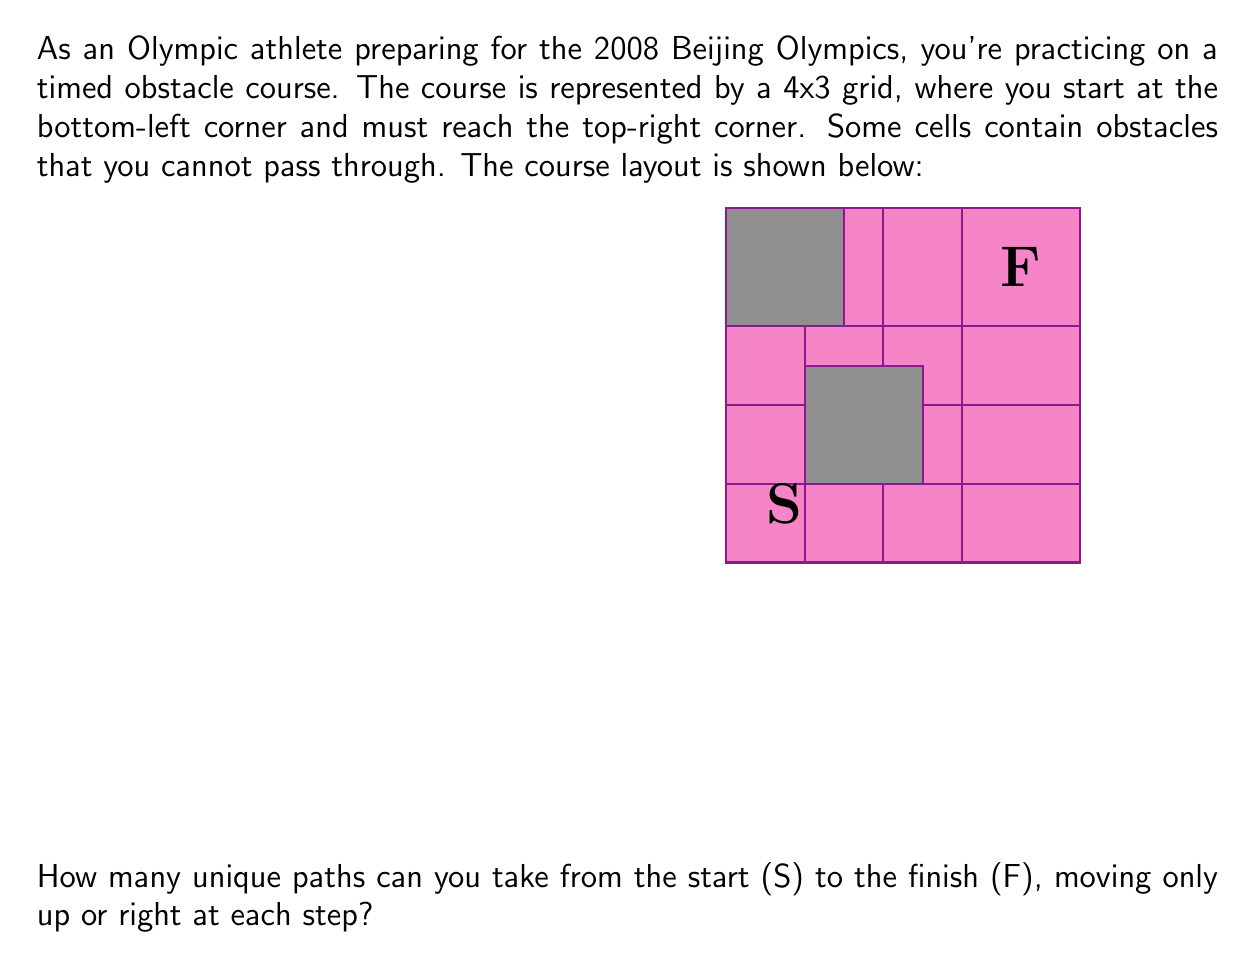Give your solution to this math problem. Let's approach this step-by-step:

1) First, we need to understand that this is a combinatorics problem where we're counting paths on a grid with obstacles.

2) We can solve this using dynamic programming. Let's create a 4x3 matrix where each cell represents the number of ways to reach that cell from the start.

3) Initialize the matrix:
   - Set the start position (0,0) to 1
   - Set obstacle positions to 0
   - Set all other positions to 0 initially

4) Fill the matrix:
   - For each cell (i,j), the number of ways to reach it is the sum of ways to reach the cell to its left (i,j-1) and the cell below it (i-1,j)
   - Skip obstacle cells

5) Let's fill the matrix step by step:

   $$\begin{bmatrix}
   0 & 0 & 1 \\
   0 & 0 & 1 \\
   1 & 1 & 2 \\
   1 & 1 & 3
   \end{bmatrix}$$

6) The top-right cell (3,2) gives us the total number of unique paths: 3

Therefore, there are 3 unique paths from start to finish.
Answer: 3 